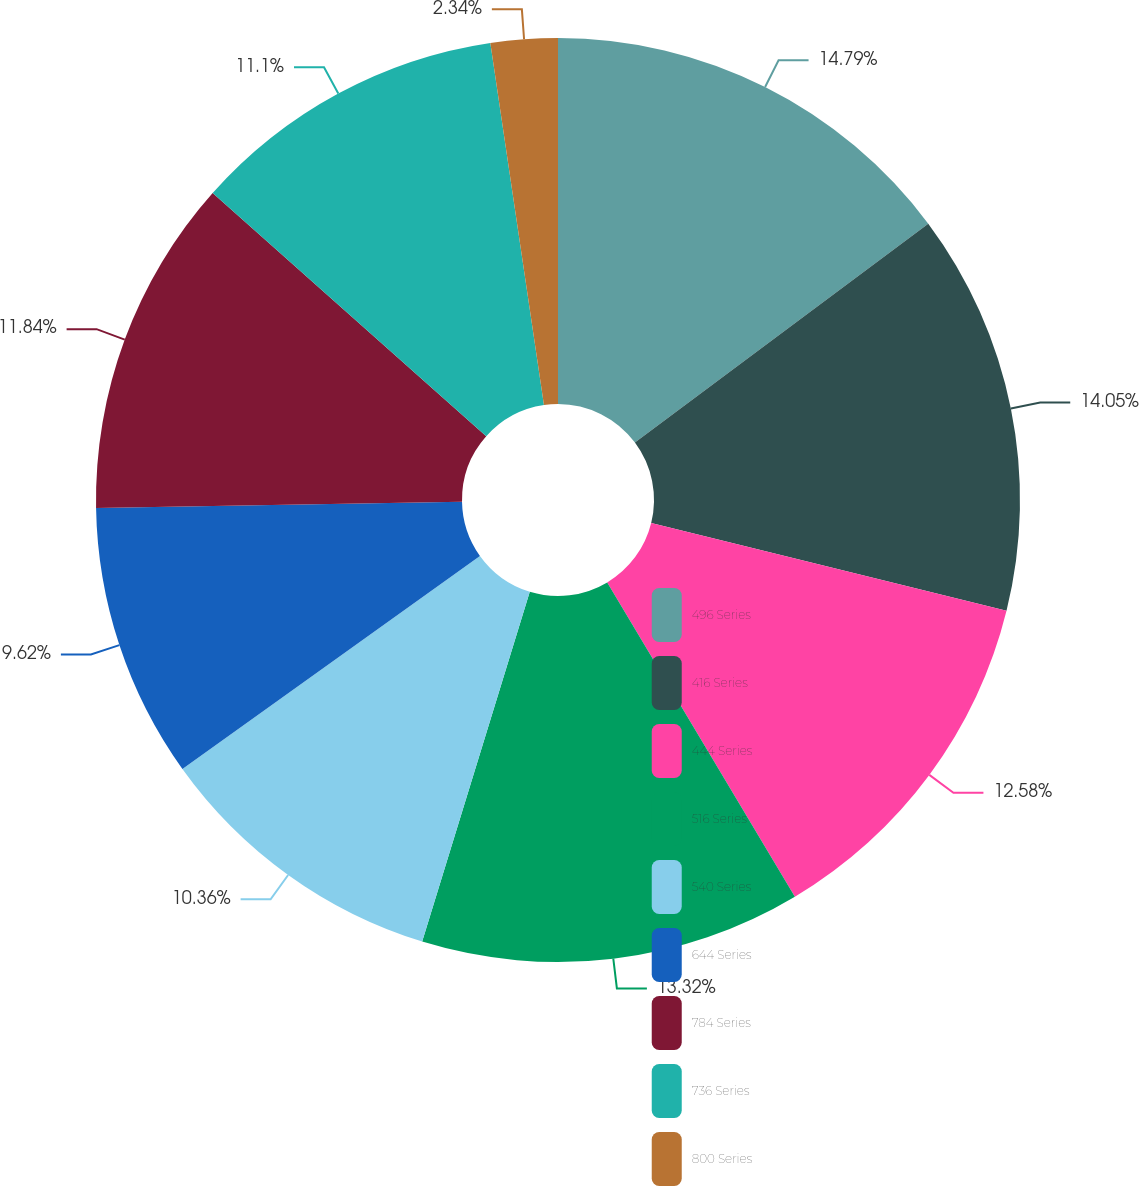Convert chart to OTSL. <chart><loc_0><loc_0><loc_500><loc_500><pie_chart><fcel>496 Series<fcel>416 Series<fcel>444 Series<fcel>516 Series<fcel>540 Series<fcel>644 Series<fcel>784 Series<fcel>736 Series<fcel>800 Series<nl><fcel>14.8%<fcel>14.06%<fcel>12.58%<fcel>13.32%<fcel>10.36%<fcel>9.62%<fcel>11.84%<fcel>11.1%<fcel>2.34%<nl></chart> 